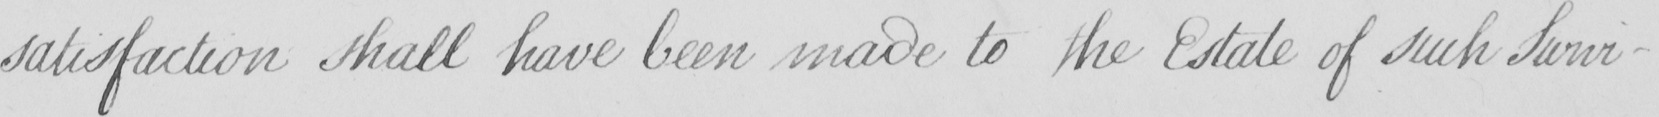Please transcribe the handwritten text in this image. satisfaction shall have been made to the Estate of such Survi- 